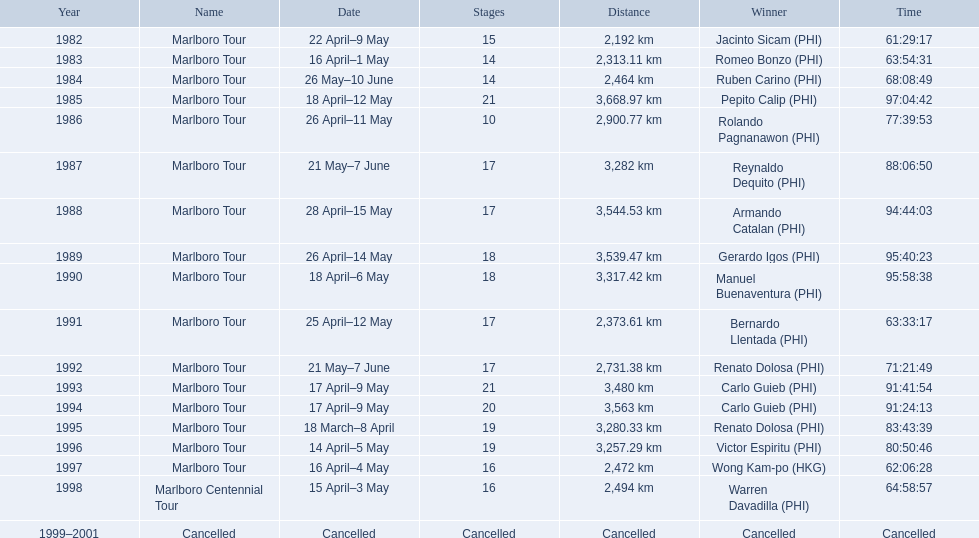In what year did warren davdilla (w.d.) emerge? 1998. What route did w.d. accomplish? Marlboro Centennial Tour. What is the time documented in the identical row as w.d.? 64:58:57. What were the race names during le tour de filipinas? Marlboro Tour, Marlboro Tour, Marlboro Tour, Marlboro Tour, Marlboro Tour, Marlboro Tour, Marlboro Tour, Marlboro Tour, Marlboro Tour, Marlboro Tour, Marlboro Tour, Marlboro Tour, Marlboro Tour, Marlboro Tour, Marlboro Tour, Marlboro Tour, Marlboro Centennial Tour, Cancelled. What were the noted distances for each marlboro tour? 2,192 km, 2,313.11 km, 2,464 km, 3,668.97 km, 2,900.77 km, 3,282 km, 3,544.53 km, 3,539.47 km, 3,317.42 km, 2,373.61 km, 2,731.38 km, 3,480 km, 3,563 km, 3,280.33 km, 3,257.29 km, 2,472 km. And from those distances, which was the lengthiest? 3,668.97 km. 